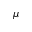Convert formula to latex. <formula><loc_0><loc_0><loc_500><loc_500>\mu</formula> 